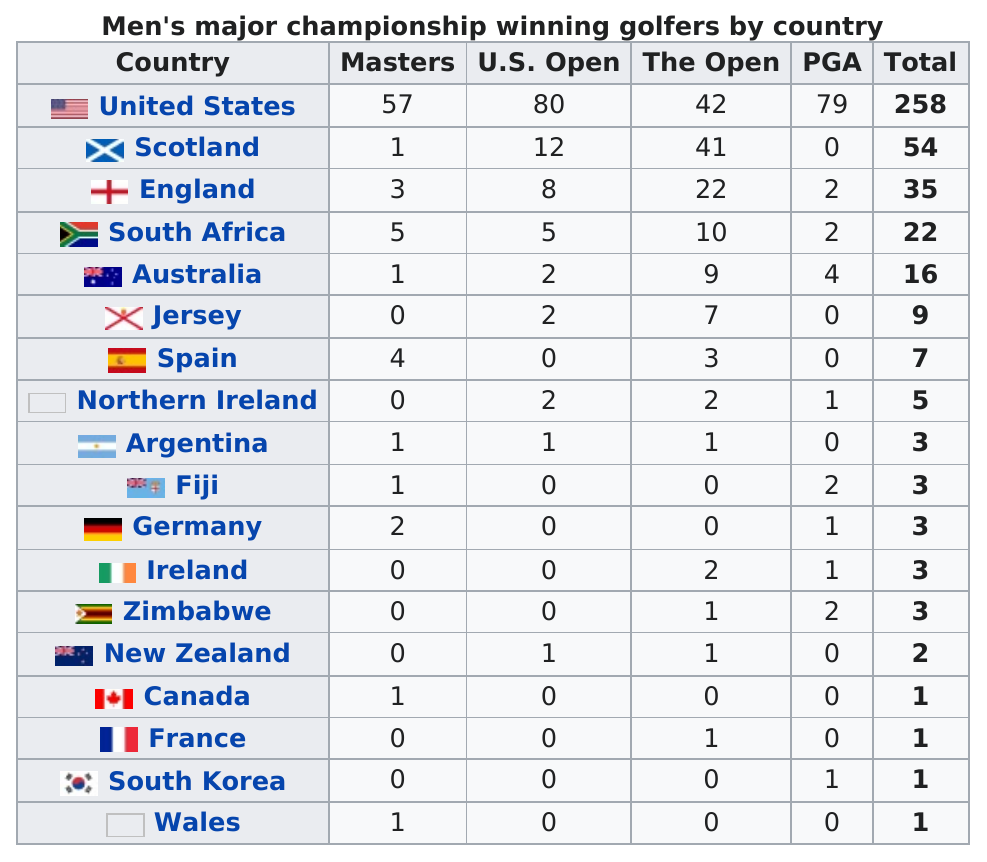Point out several critical features in this image. Spain has won a total of 7 championships. As of today, there have been two PGA winning golfers from Zimbabwe. The United States comes in first place. England and Wales have a total of four winning golfers in the Masters. According to the table, Zimbabwe has the least number of champion golfers among African countries. 